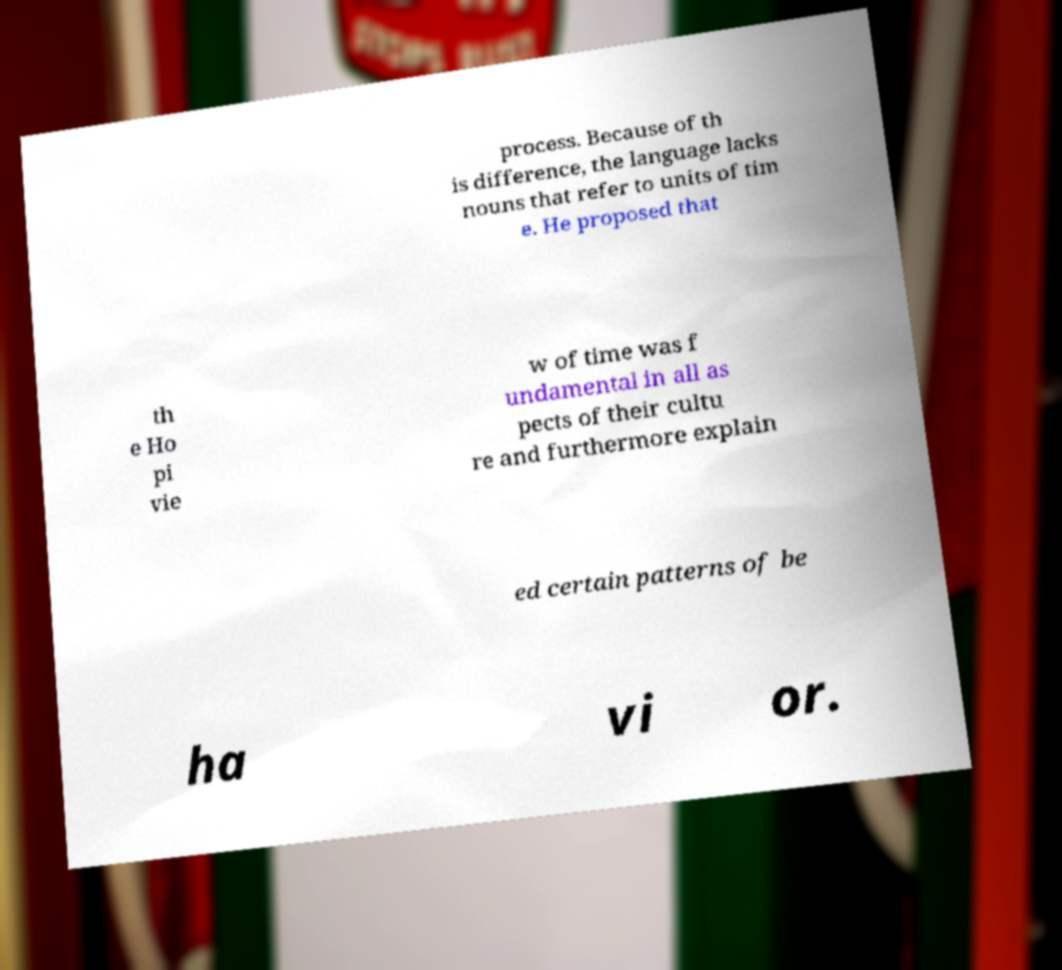Can you accurately transcribe the text from the provided image for me? process. Because of th is difference, the language lacks nouns that refer to units of tim e. He proposed that th e Ho pi vie w of time was f undamental in all as pects of their cultu re and furthermore explain ed certain patterns of be ha vi or. 